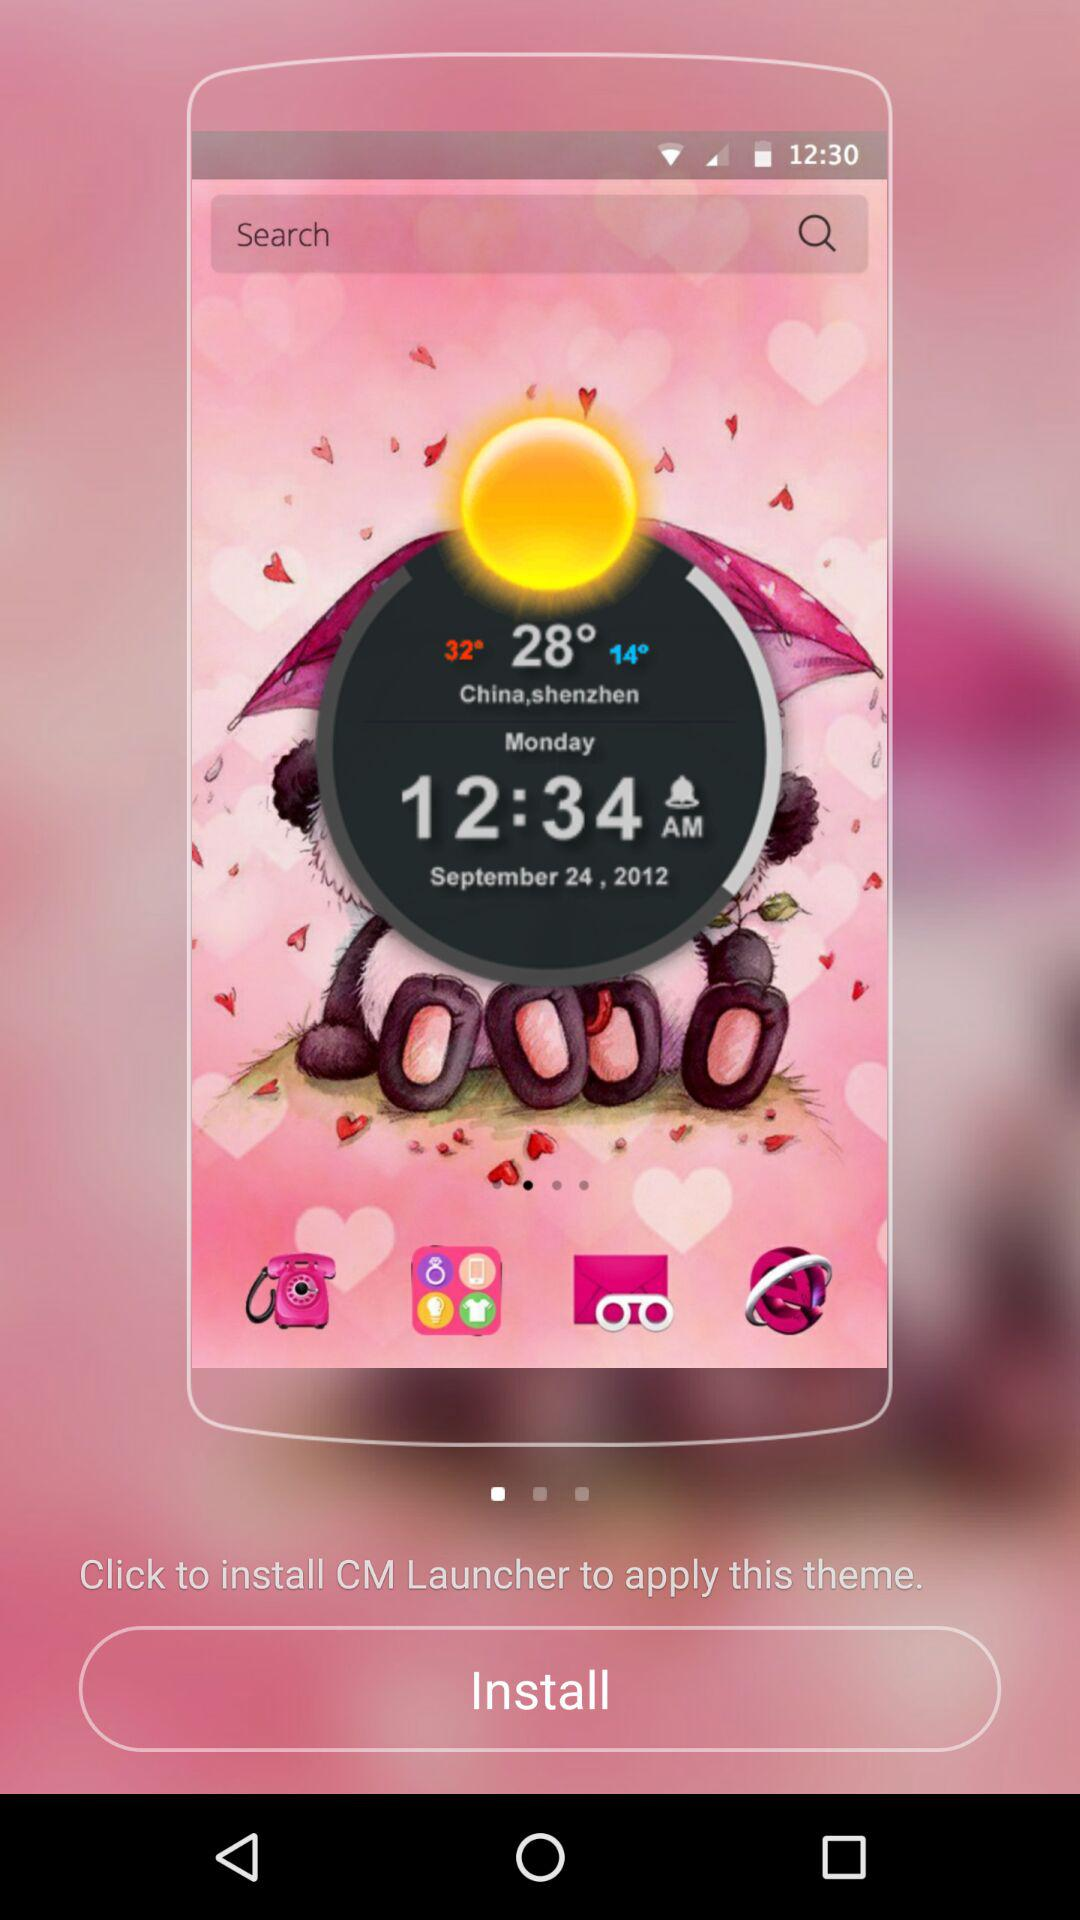How many themes are there in total?
When the provided information is insufficient, respond with <no answer>. <no answer> 